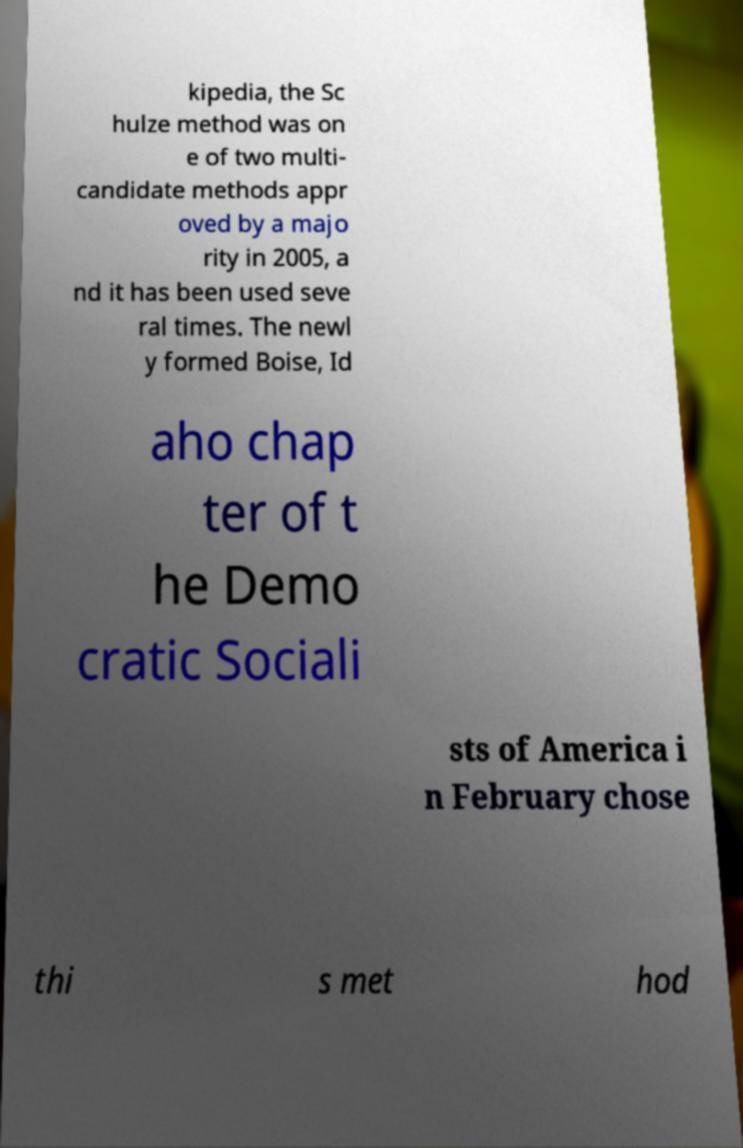Please identify and transcribe the text found in this image. kipedia, the Sc hulze method was on e of two multi- candidate methods appr oved by a majo rity in 2005, a nd it has been used seve ral times. The newl y formed Boise, Id aho chap ter of t he Demo cratic Sociali sts of America i n February chose thi s met hod 